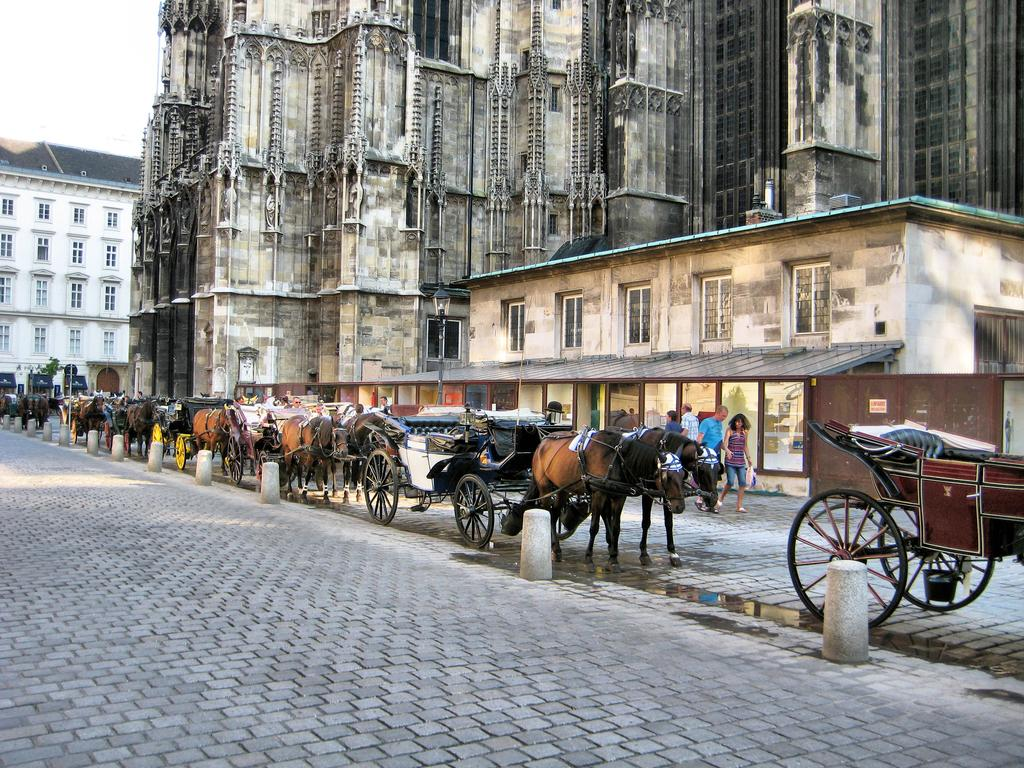What type of vehicles can be seen in the image? There are horse carts in the image. What else is present in the image besides the horse carts? There are people in the street and buildings visible in the image. How many pencils can be seen in the image? There are no pencils present in the image. What type of beds can be seen in the image? There are no beds present in the image. 